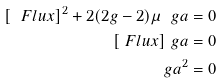Convert formula to latex. <formula><loc_0><loc_0><loc_500><loc_500>[ \ F l u x ] ^ { 2 } + 2 ( 2 g - 2 ) \mu \ g a & = 0 \\ [ \ F l u x ] \ g a & = 0 \\ \ g a ^ { 2 } & = 0</formula> 